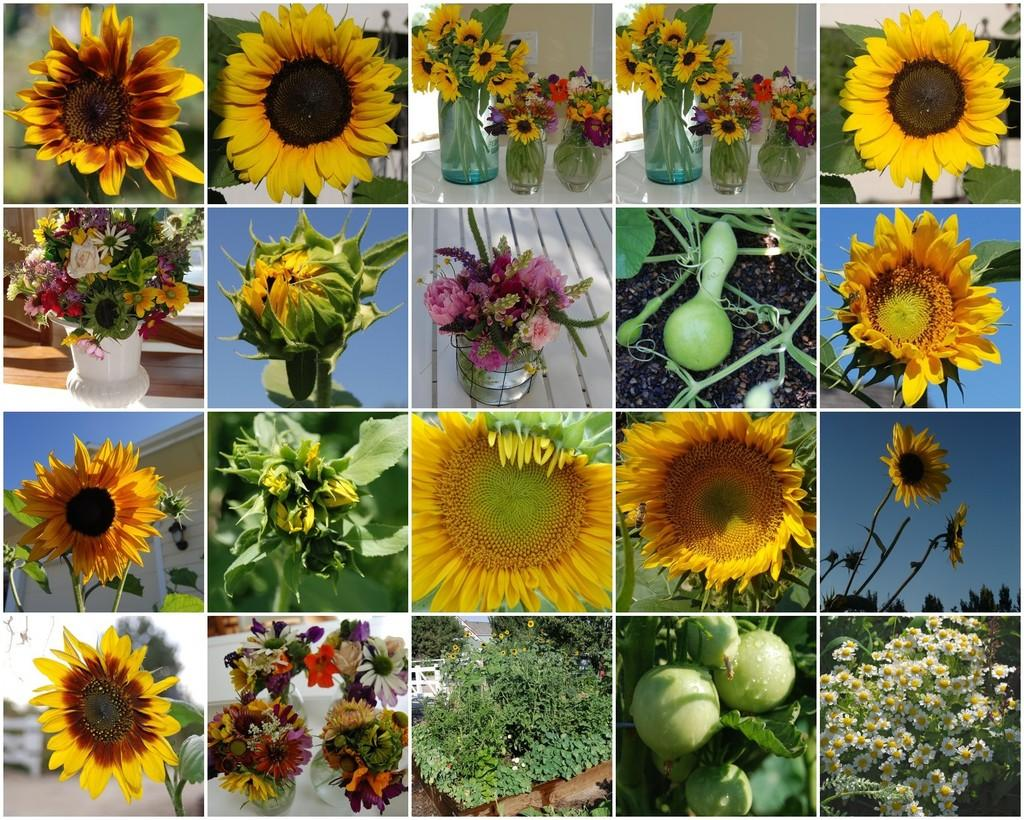What is the main subject of the image? The main subject of the image is a collage of flower pictures. Can you describe the content of the collage? The collage contains pictures of various flowers. How many rabbits can be seen in the image? There are no rabbits present in the image; it contains a collage of flower pictures. 